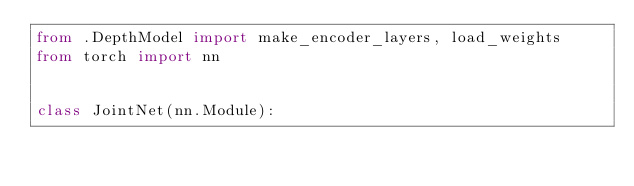<code> <loc_0><loc_0><loc_500><loc_500><_Python_>from .DepthModel import make_encoder_layers, load_weights
from torch import nn


class JointNet(nn.Module):
</code> 